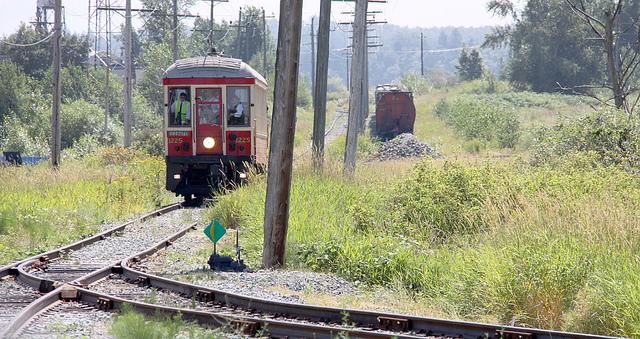Is the grass tall?
Be succinct. Yes. How many trains are there?
Quick response, please. 2. How many lights are on the train?
Concise answer only. 1. 